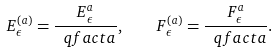<formula> <loc_0><loc_0><loc_500><loc_500>E _ { \epsilon } ^ { ( a ) } = \frac { E _ { \epsilon } ^ { a } } { \ q f a c t { a } } , \quad F _ { \epsilon } ^ { ( a ) } = \frac { F _ { \epsilon } ^ { a } } { \ q f a c t { a } } .</formula> 